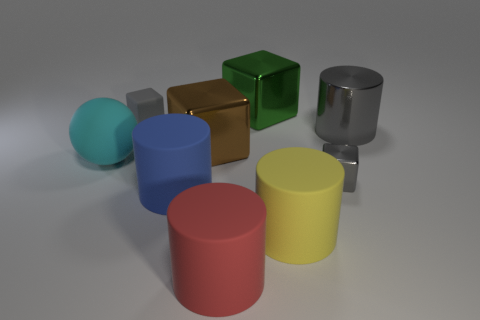What is the material of the blue thing that is the same shape as the large red matte thing?
Make the answer very short. Rubber. There is a metallic object that is behind the cylinder that is behind the gray cube that is right of the green metal thing; what color is it?
Offer a very short reply. Green. Do the tiny gray object right of the gray matte cube and the brown thing have the same material?
Offer a very short reply. Yes. How many other objects are there of the same material as the yellow cylinder?
Keep it short and to the point. 4. There is a gray cylinder that is the same size as the green shiny cube; what is its material?
Offer a very short reply. Metal. There is a big object that is behind the small gray rubber object; is it the same shape as the small thing in front of the tiny matte object?
Provide a succinct answer. Yes. There is a blue rubber object that is the same size as the cyan rubber ball; what shape is it?
Offer a terse response. Cylinder. Are the small gray object on the right side of the small matte object and the thing that is to the left of the small rubber cube made of the same material?
Offer a very short reply. No. There is a gray cube to the right of the yellow matte thing; are there any gray metal cylinders that are on the left side of it?
Provide a succinct answer. No. The small block that is made of the same material as the blue cylinder is what color?
Ensure brevity in your answer.  Gray. 